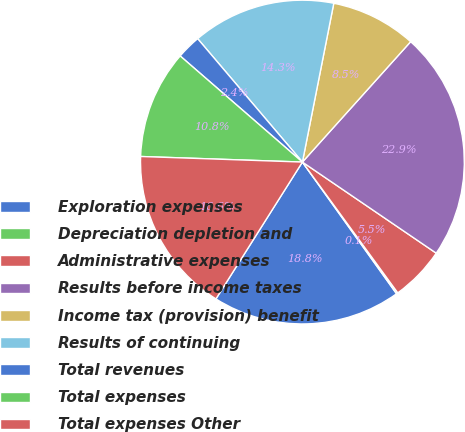Convert chart to OTSL. <chart><loc_0><loc_0><loc_500><loc_500><pie_chart><fcel>Exploration expenses<fcel>Depreciation depletion and<fcel>Administrative expenses<fcel>Results before income taxes<fcel>Income tax (provision) benefit<fcel>Results of continuing<fcel>Total revenues<fcel>Total expenses<fcel>Total expenses Other<nl><fcel>18.85%<fcel>0.15%<fcel>5.46%<fcel>22.86%<fcel>8.55%<fcel>14.31%<fcel>2.42%<fcel>10.83%<fcel>16.58%<nl></chart> 